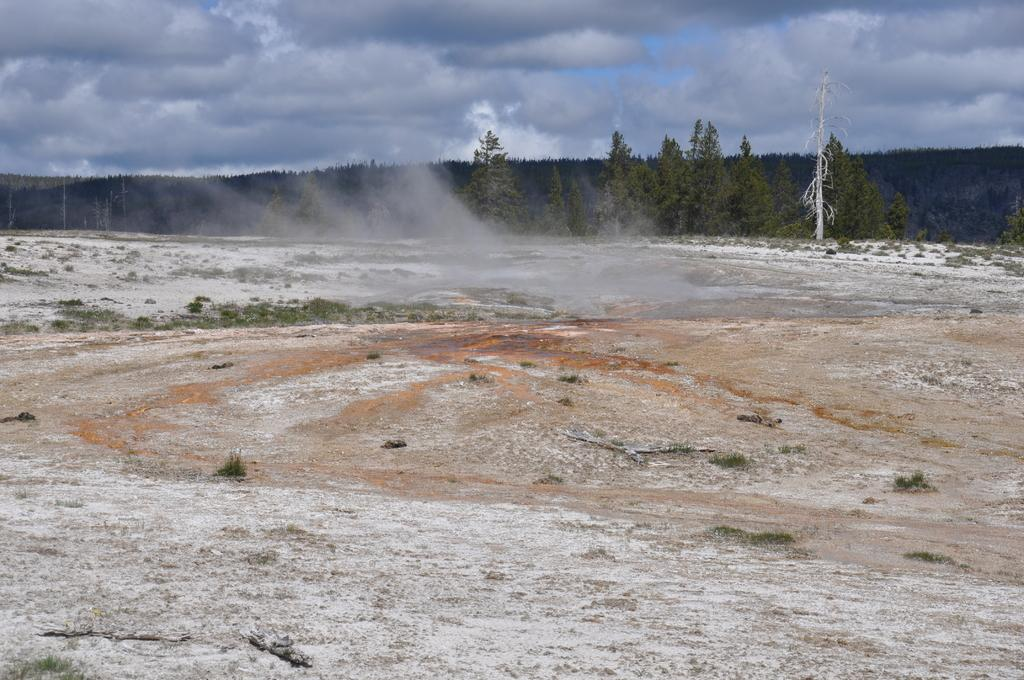What type of vegetation can be seen in the image? There are trees and grass visible in the image. What can be seen on the ground in the image? The ground is visible in the image with some objects. What is the color of the white-colored object in the image? The white-colored object in the image is white. What is visible in the sky in the image? The sky is visible in the image with clouds. Can you tell me how many grapes are hanging from the trees in the image? There are no grapes visible in the image; the trees are not fruit-bearing trees. What type of creature is seen sleeping in the crib in the image? There is no crib present in the image, so this question cannot be answered. 